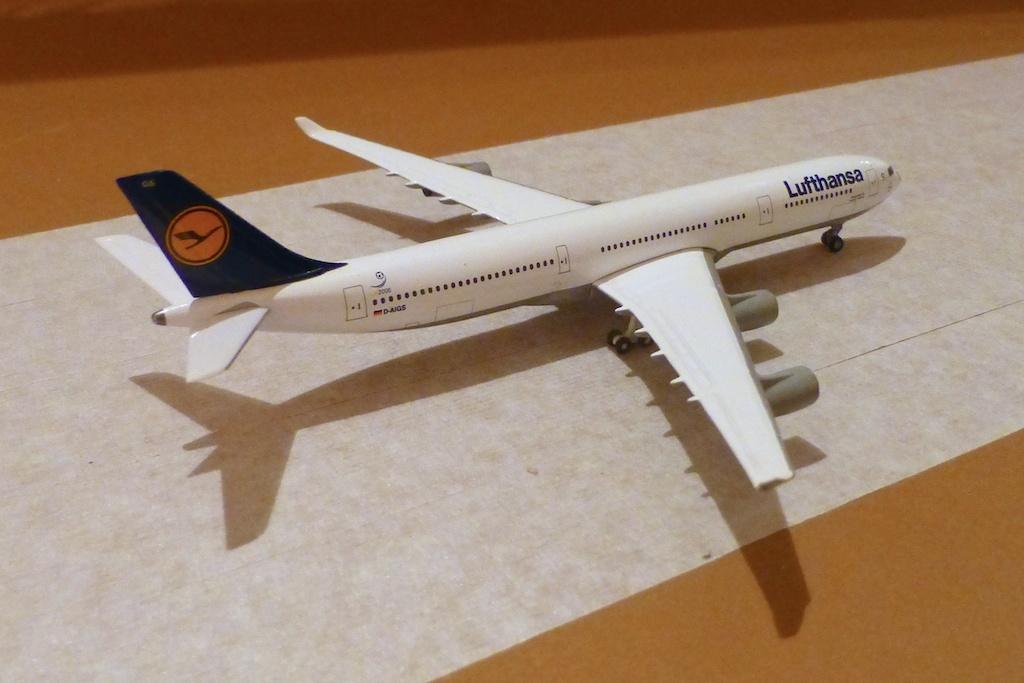Could you give a brief overview of what you see in this image? In this image there is a aeroplane toy on the table. 